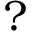<formula> <loc_0><loc_0><loc_500><loc_500>?</formula> 